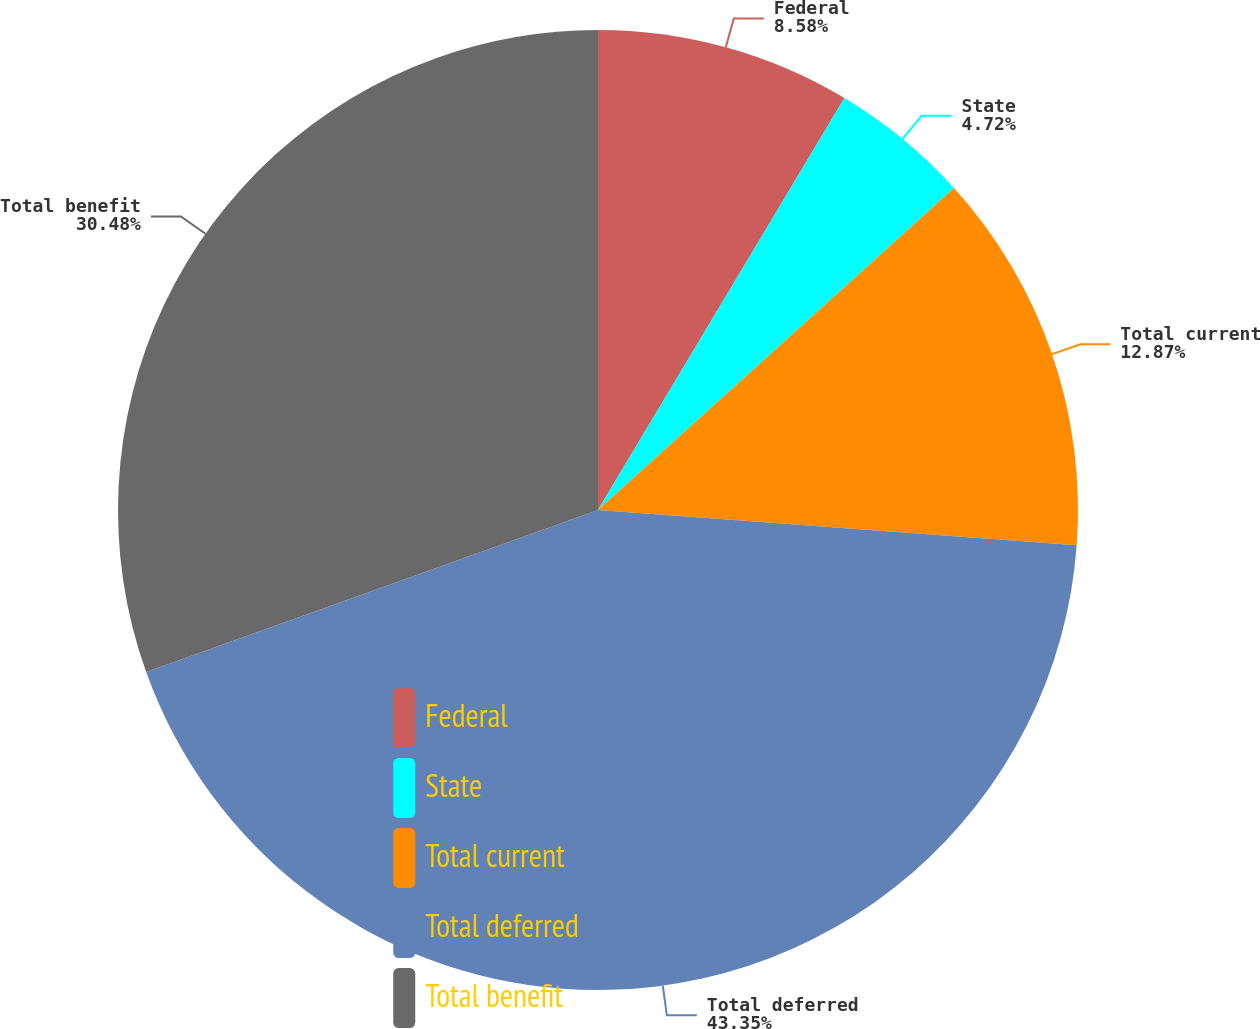Convert chart. <chart><loc_0><loc_0><loc_500><loc_500><pie_chart><fcel>Federal<fcel>State<fcel>Total current<fcel>Total deferred<fcel>Total benefit<nl><fcel>8.58%<fcel>4.72%<fcel>12.87%<fcel>43.35%<fcel>30.48%<nl></chart> 